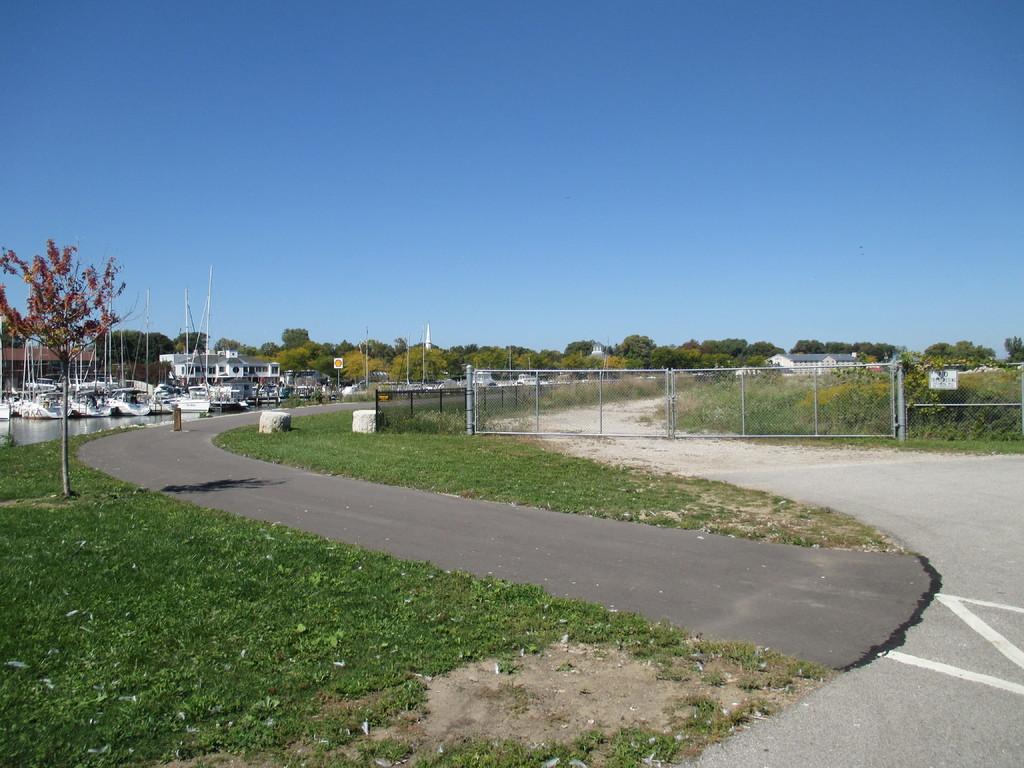Can you describe this image briefly? In this image we can see the trees, poles, plants, grass, fence and also some rods. We can also see the road and also the boats on the surface of the water. We can see the building. Sky is also visible in this image. 